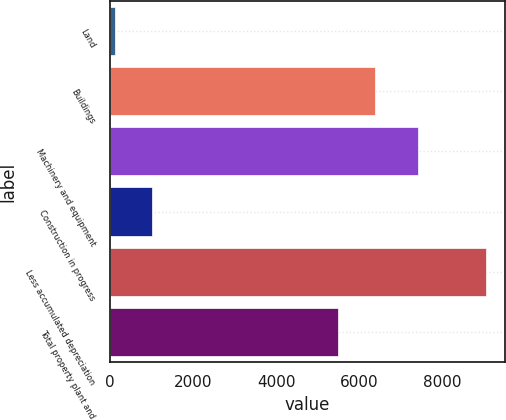Convert chart to OTSL. <chart><loc_0><loc_0><loc_500><loc_500><bar_chart><fcel>Land<fcel>Buildings<fcel>Machinery and equipment<fcel>Construction in progress<fcel>Less accumulated depreciation<fcel>Total property plant and<nl><fcel>123<fcel>6383.4<fcel>7409<fcel>1016.4<fcel>9057<fcel>5490<nl></chart> 